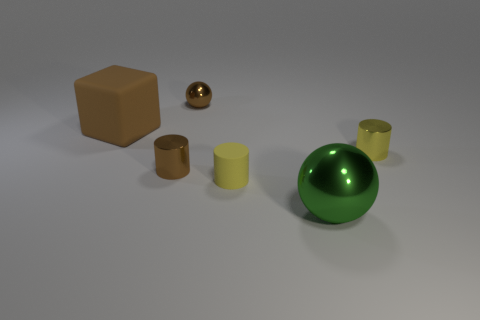Subtract all small brown cylinders. How many cylinders are left? 2 Add 2 large red matte cylinders. How many objects exist? 8 Subtract all green balls. How many balls are left? 1 Subtract all spheres. How many objects are left? 4 Subtract 1 cylinders. How many cylinders are left? 2 Add 5 tiny brown cylinders. How many tiny brown cylinders exist? 6 Subtract 1 yellow cylinders. How many objects are left? 5 Subtract all gray blocks. Subtract all yellow cylinders. How many blocks are left? 1 Subtract all blue cylinders. How many red spheres are left? 0 Subtract all big yellow things. Subtract all brown rubber objects. How many objects are left? 5 